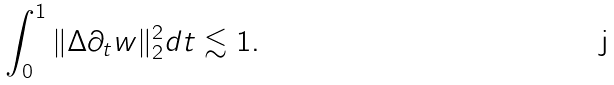Convert formula to latex. <formula><loc_0><loc_0><loc_500><loc_500>\int _ { 0 } ^ { 1 } \| \Delta \partial _ { t } w \| _ { 2 } ^ { 2 } d t \lesssim 1 .</formula> 